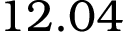Convert formula to latex. <formula><loc_0><loc_0><loc_500><loc_500>1 2 . 0 4</formula> 